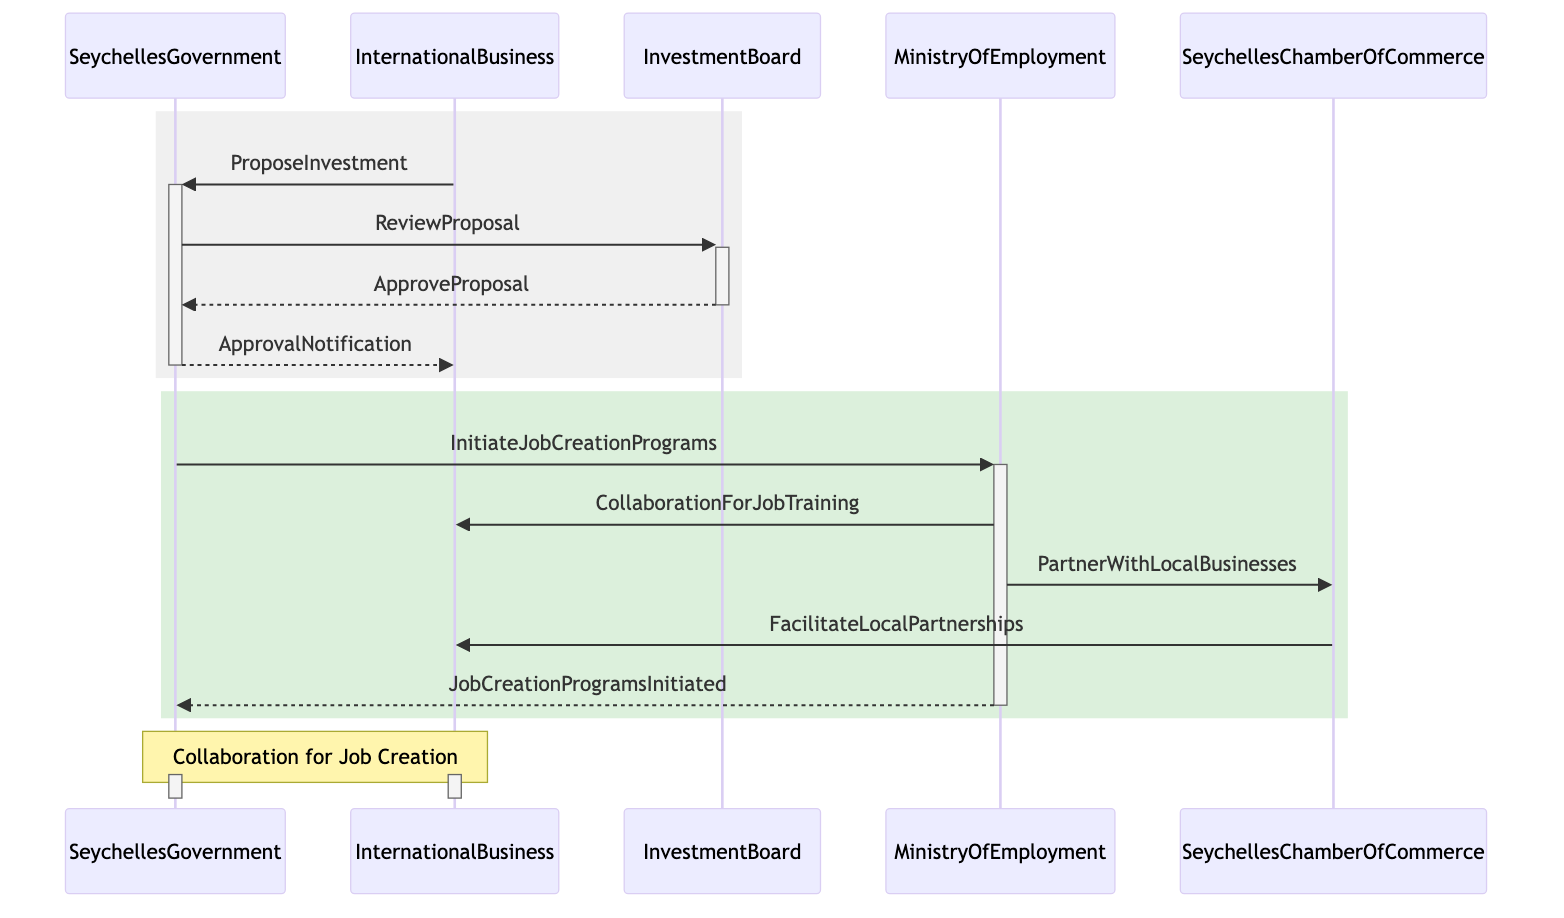What is the first message sent in the sequence? The first message in the sequence is sent from the InternationalBusiness to the SeychellesGovernment, labelled "ProposeInvestment."
Answer: ProposeInvestment How many entities are involved in the collaboration? There are three entities involved: InvestmentBoard, MinistryOfEmployment, and SeychellesChamberOfCommerce.
Answer: Three What action follows the proposal review? After the SeychellesGovernment reviews the proposal, the next action is for the InvestmentBoard to approve it, labelled "ApproveProposal."
Answer: ApproveProposal What is the role of the SeychellesChamberOfCommerce in this diagram? The SeychellesChamberOfCommerce's role is to facilitate local partnerships, evidenced by the message "FacilitateLocalPartnerships" sent to InternationalBusiness.
Answer: FacilitateLocalPartnerships Which entity initiates the job creation programs? The entity that initiates the job creation programs is the MinistryOfEmployment, as indicated by the message "InitiateJobCreationPrograms."
Answer: MinistryOfEmployment How does InternationalBusiness benefit following "ApprovalNotification"? Following "ApprovalNotification," InternationalBusiness benefits from receiving collaboration for job training from the MinistryOfEmployment.
Answer: CollaborationForJobTraining What is the final step indicated in the diagram? The final step indicated in the diagram is the completion of job creation programs, marked by the return message "JobCreationProgramsInitiated" to SeychellesGovernment from MinistryOfEmployment.
Answer: JobCreationProgramsInitiated How many messages are exchanged between InternationalBusiness and SeychellesGovernment? There are two messages exchanged: "ProposeInvestment" and "ApprovalNotification."
Answer: Two Which two entities collaborate to support local businesses? The MinistryOfEmployment and SeychellesChamberOfCommerce collaborate to support local businesses through the message "PartnerWithLocalBusinesses."
Answer: MinistryOfEmployment and SeychellesChamberOfCommerce 